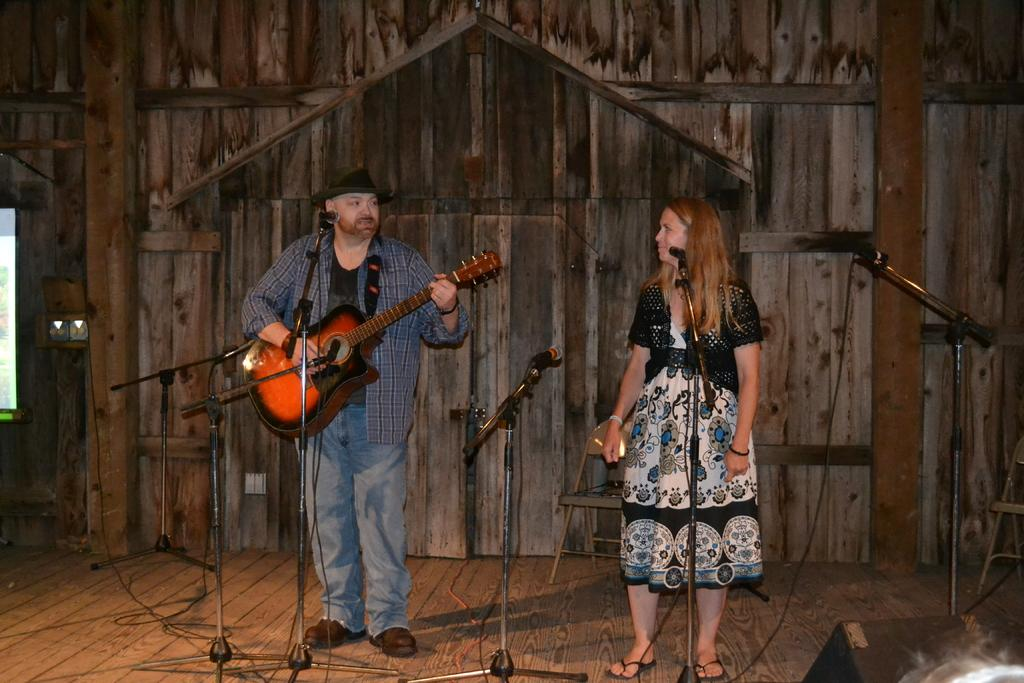What is the man doing on the left side of the image? The man is playing the guitar. What is the man wearing on his head? The man is wearing a hat. What is the woman doing on the right side of the image? The woman is standing on the right side of the image. What color is the dress the woman is wearing? The woman is wearing a black color dress. What type of basket is the man using to play the guitar in the image? There is no basket present in the image, and the man is not using any basket to play the guitar. 